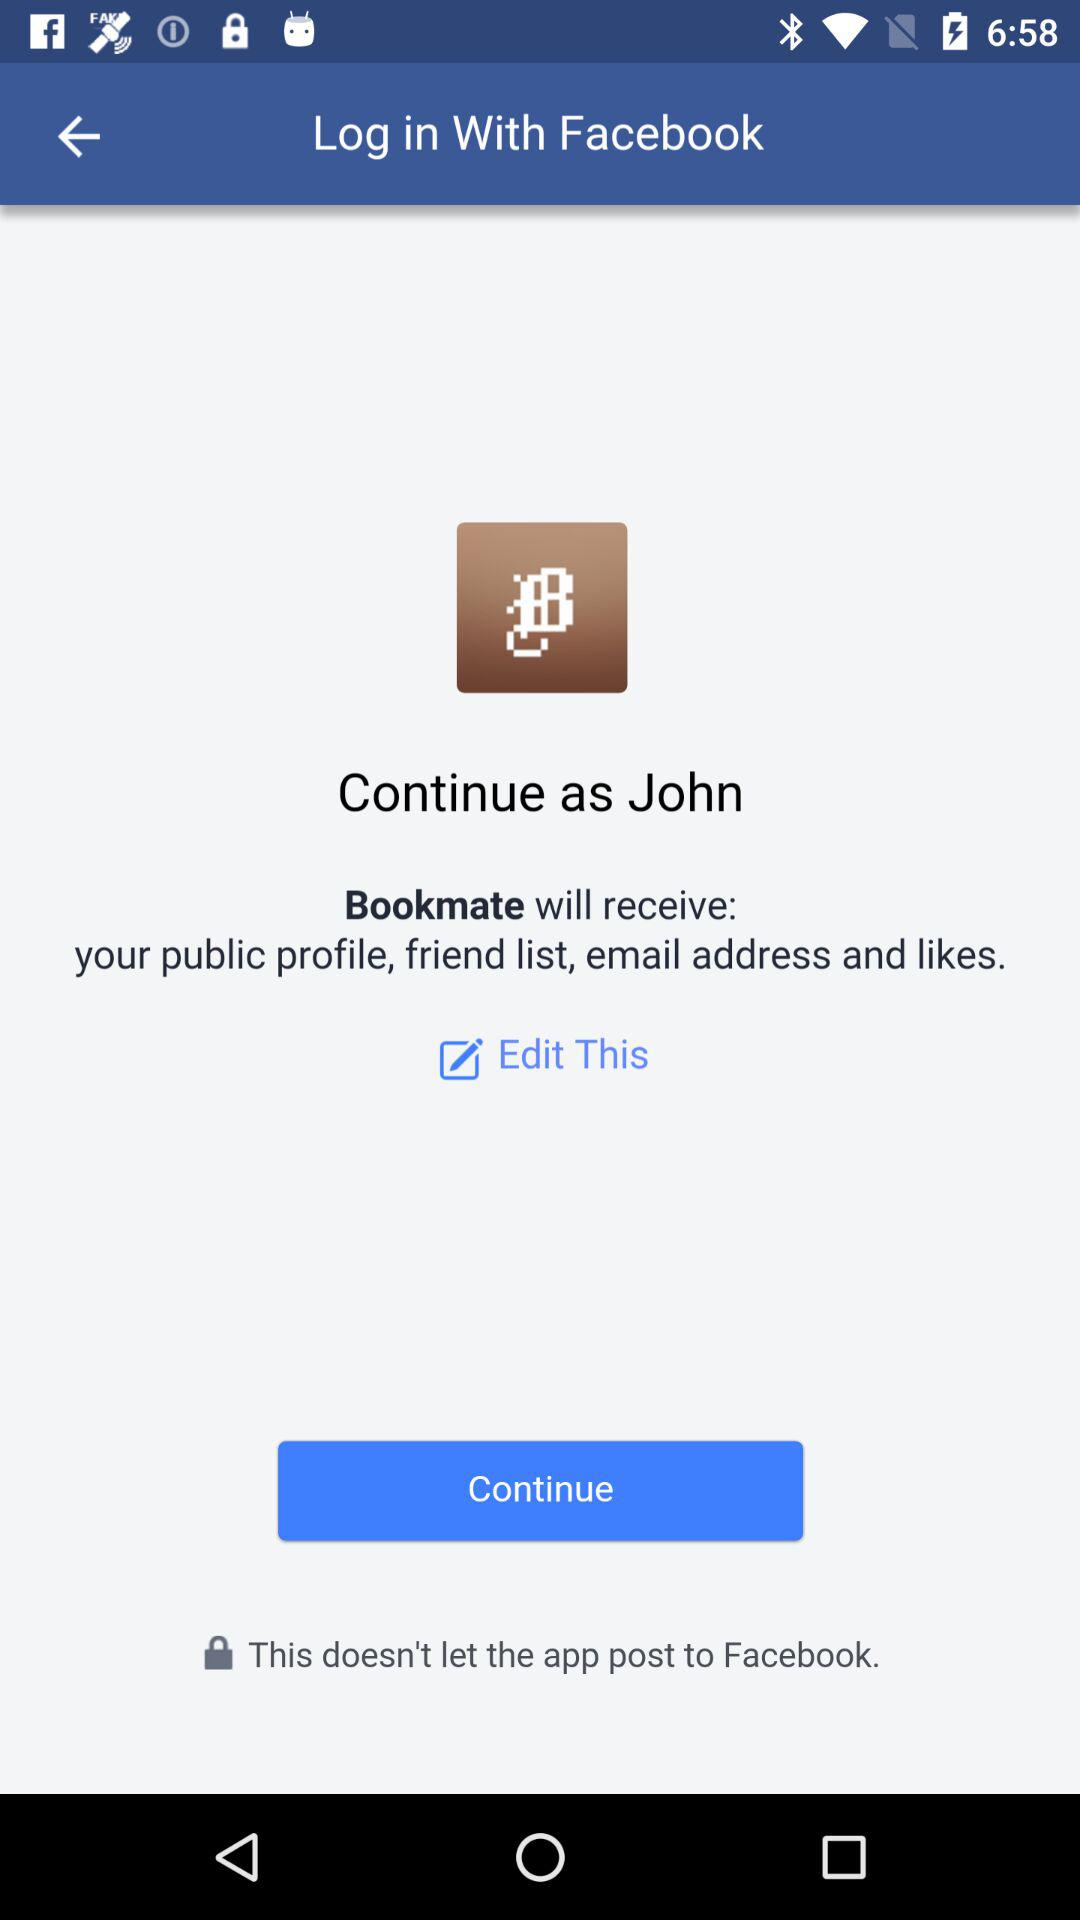What is the name of the user? The name of the user is John. 